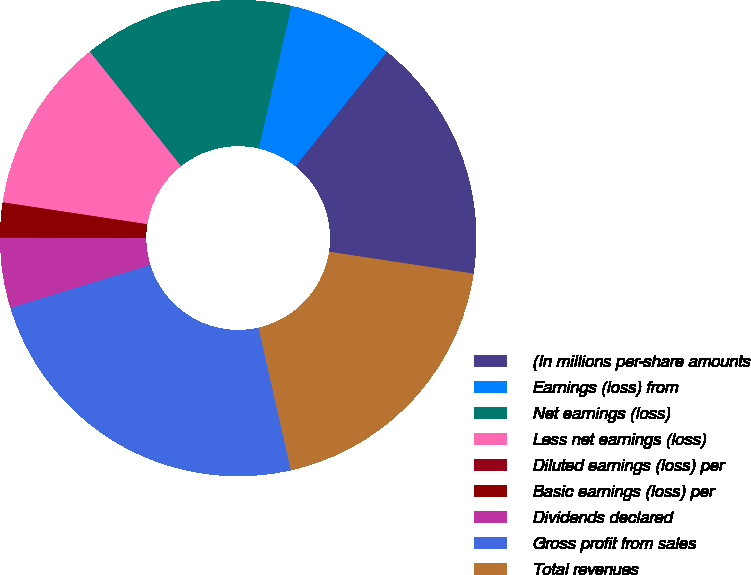Convert chart to OTSL. <chart><loc_0><loc_0><loc_500><loc_500><pie_chart><fcel>(In millions per-share amounts<fcel>Earnings (loss) from<fcel>Net earnings (loss)<fcel>Less net earnings (loss)<fcel>Diluted earnings (loss) per<fcel>Basic earnings (loss) per<fcel>Dividends declared<fcel>Gross profit from sales<fcel>Total revenues<nl><fcel>16.67%<fcel>7.14%<fcel>14.29%<fcel>11.9%<fcel>0.0%<fcel>2.38%<fcel>4.76%<fcel>23.81%<fcel>19.05%<nl></chart> 